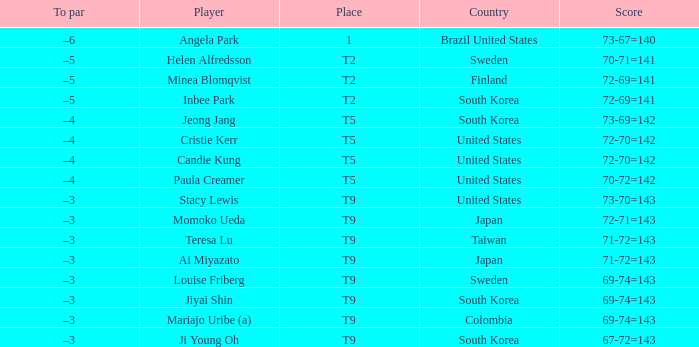Which country placed t9 and had the player jiyai shin? South Korea. 